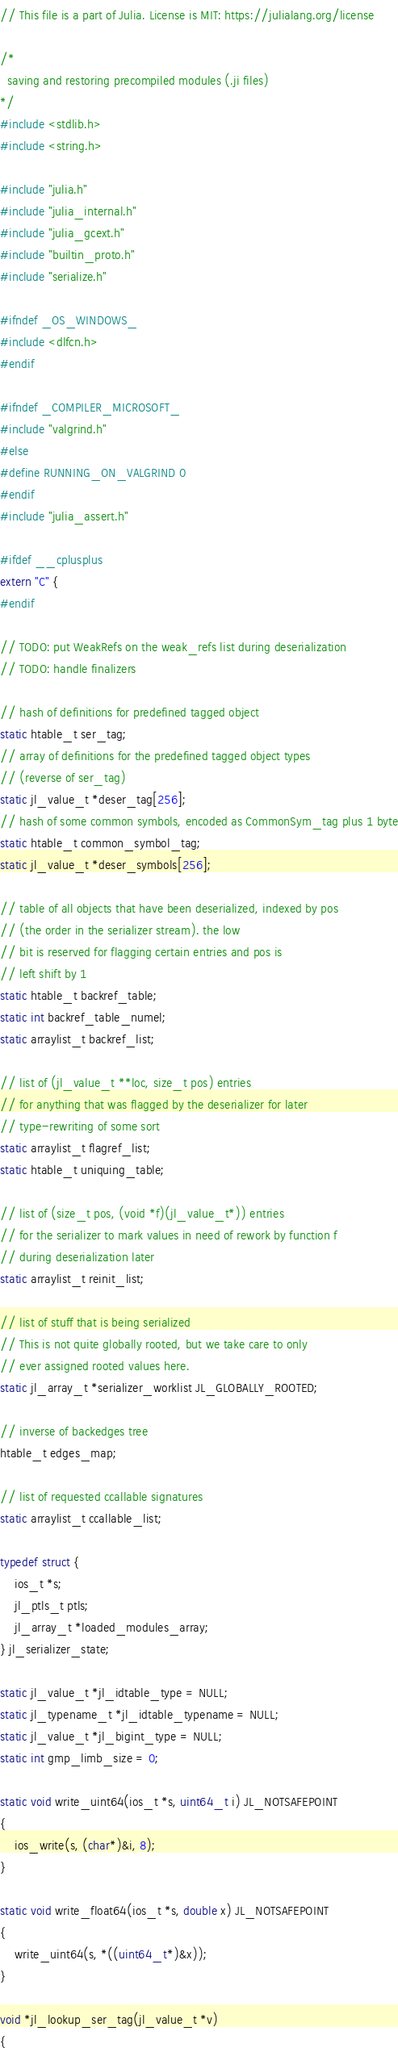<code> <loc_0><loc_0><loc_500><loc_500><_C_>// This file is a part of Julia. License is MIT: https://julialang.org/license

/*
  saving and restoring precompiled modules (.ji files)
*/
#include <stdlib.h>
#include <string.h>

#include "julia.h"
#include "julia_internal.h"
#include "julia_gcext.h"
#include "builtin_proto.h"
#include "serialize.h"

#ifndef _OS_WINDOWS_
#include <dlfcn.h>
#endif

#ifndef _COMPILER_MICROSOFT_
#include "valgrind.h"
#else
#define RUNNING_ON_VALGRIND 0
#endif
#include "julia_assert.h"

#ifdef __cplusplus
extern "C" {
#endif

// TODO: put WeakRefs on the weak_refs list during deserialization
// TODO: handle finalizers

// hash of definitions for predefined tagged object
static htable_t ser_tag;
// array of definitions for the predefined tagged object types
// (reverse of ser_tag)
static jl_value_t *deser_tag[256];
// hash of some common symbols, encoded as CommonSym_tag plus 1 byte
static htable_t common_symbol_tag;
static jl_value_t *deser_symbols[256];

// table of all objects that have been deserialized, indexed by pos
// (the order in the serializer stream). the low
// bit is reserved for flagging certain entries and pos is
// left shift by 1
static htable_t backref_table;
static int backref_table_numel;
static arraylist_t backref_list;

// list of (jl_value_t **loc, size_t pos) entries
// for anything that was flagged by the deserializer for later
// type-rewriting of some sort
static arraylist_t flagref_list;
static htable_t uniquing_table;

// list of (size_t pos, (void *f)(jl_value_t*)) entries
// for the serializer to mark values in need of rework by function f
// during deserialization later
static arraylist_t reinit_list;

// list of stuff that is being serialized
// This is not quite globally rooted, but we take care to only
// ever assigned rooted values here.
static jl_array_t *serializer_worklist JL_GLOBALLY_ROOTED;

// inverse of backedges tree
htable_t edges_map;

// list of requested ccallable signatures
static arraylist_t ccallable_list;

typedef struct {
    ios_t *s;
    jl_ptls_t ptls;
    jl_array_t *loaded_modules_array;
} jl_serializer_state;

static jl_value_t *jl_idtable_type = NULL;
static jl_typename_t *jl_idtable_typename = NULL;
static jl_value_t *jl_bigint_type = NULL;
static int gmp_limb_size = 0;

static void write_uint64(ios_t *s, uint64_t i) JL_NOTSAFEPOINT
{
    ios_write(s, (char*)&i, 8);
}

static void write_float64(ios_t *s, double x) JL_NOTSAFEPOINT
{
    write_uint64(s, *((uint64_t*)&x));
}

void *jl_lookup_ser_tag(jl_value_t *v)
{</code> 